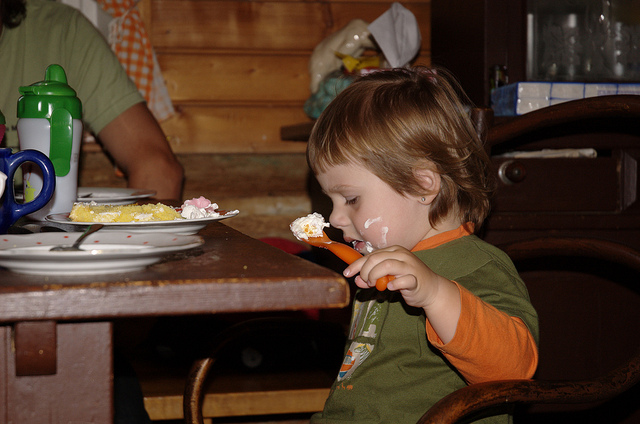<image>Is the child going to drop the cake? I am not sure if the child is going to drop the cake. Is the child going to drop the cake? I don't know if the child is going to drop the cake. It can be both yes or no. 